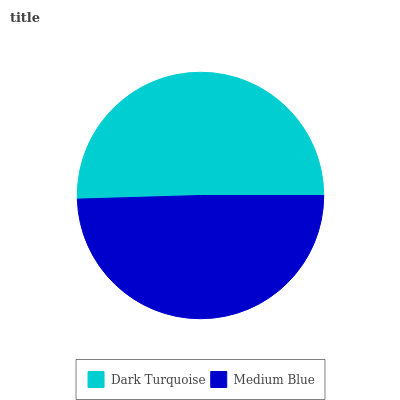Is Medium Blue the minimum?
Answer yes or no. Yes. Is Dark Turquoise the maximum?
Answer yes or no. Yes. Is Medium Blue the maximum?
Answer yes or no. No. Is Dark Turquoise greater than Medium Blue?
Answer yes or no. Yes. Is Medium Blue less than Dark Turquoise?
Answer yes or no. Yes. Is Medium Blue greater than Dark Turquoise?
Answer yes or no. No. Is Dark Turquoise less than Medium Blue?
Answer yes or no. No. Is Dark Turquoise the high median?
Answer yes or no. Yes. Is Medium Blue the low median?
Answer yes or no. Yes. Is Medium Blue the high median?
Answer yes or no. No. Is Dark Turquoise the low median?
Answer yes or no. No. 